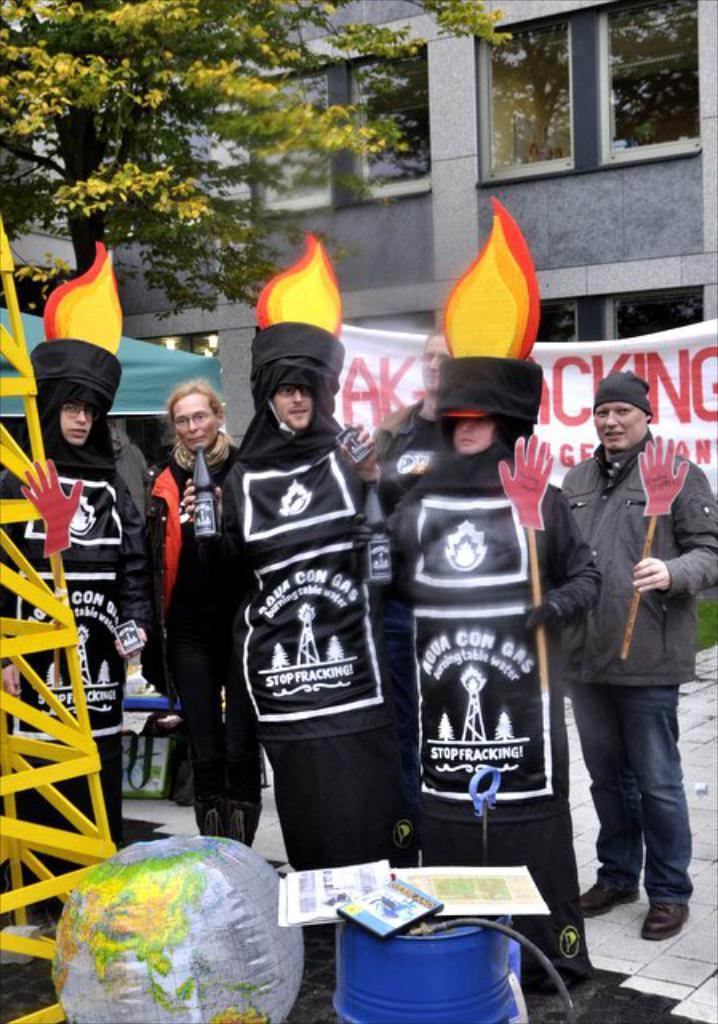Can you describe this image briefly? In this image I can see the group of people wearing the black color dresses. And I can see two people holding the sticks few people are holding the bottles. In-front of these people there is a yellow color rod and some objects. In the back there is a banner, tent, trees and the building. 